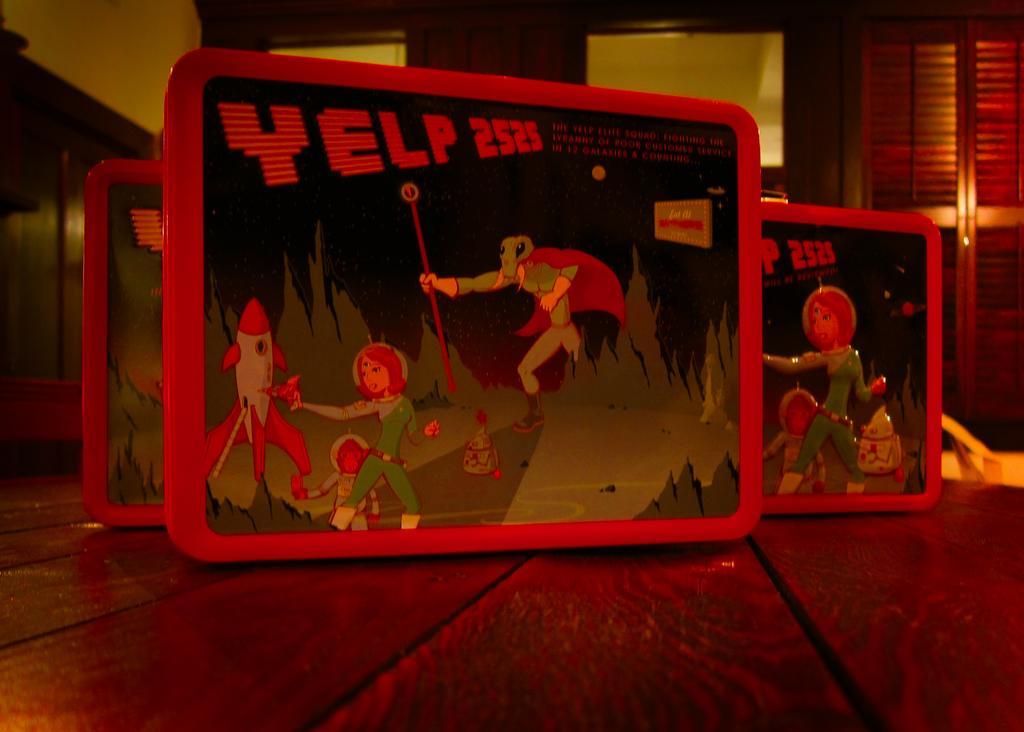Can you describe this image briefly? In this image there is a wooden object towards the bottom of the image that looks like a table, there are objects on the table, there is text on the object, there is an animal, the animal is holding an object, there is a woman, there is a man, there is a rocket, there is ground, there are objects on the ground, there is a wooden object towards the left of the image, there is an object towards the right of the image, there are wooden objects towards the top of the image, there is a door towards the right of the image, there is a wall towards the top of the image. 